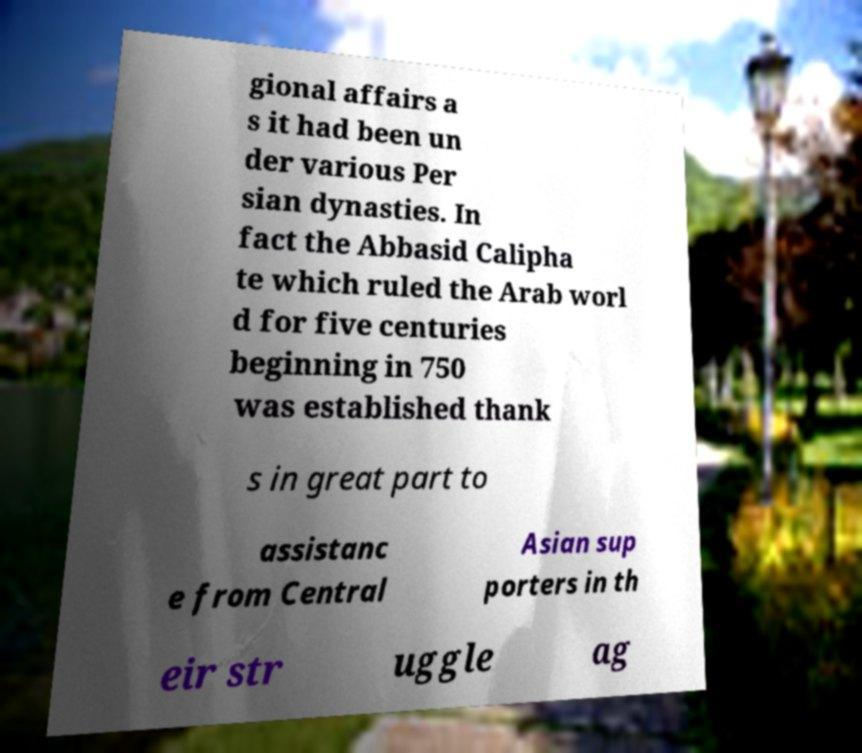Could you extract and type out the text from this image? gional affairs a s it had been un der various Per sian dynasties. In fact the Abbasid Calipha te which ruled the Arab worl d for five centuries beginning in 750 was established thank s in great part to assistanc e from Central Asian sup porters in th eir str uggle ag 